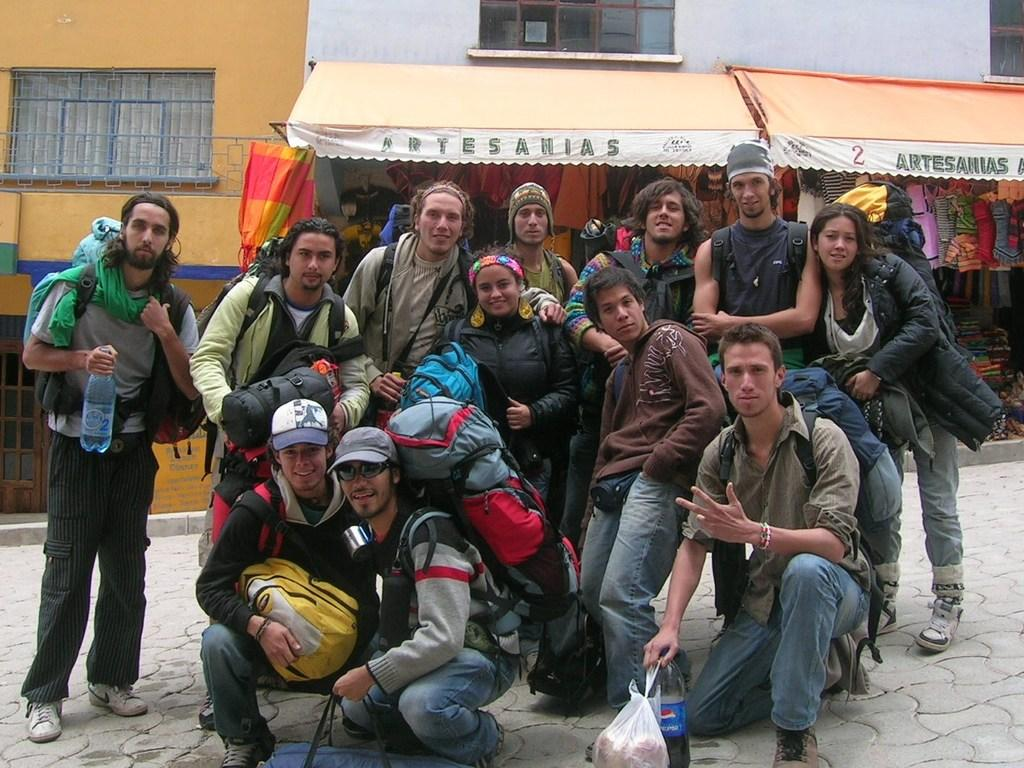What can be seen in the image? There is a group of people and stalls visible in the image. What type of items might be sold at the stalls? Clothes are visible in the image, so it's possible that the stalls are selling clothes. What is visible in the background of the image? There are buildings in the background of the image. Are there any bears visible in the image? No, there are no bears present in the image. What type of lipstick is the bear wearing in the image? There is no bear, let alone a bear wearing lipstick, present in the image. 